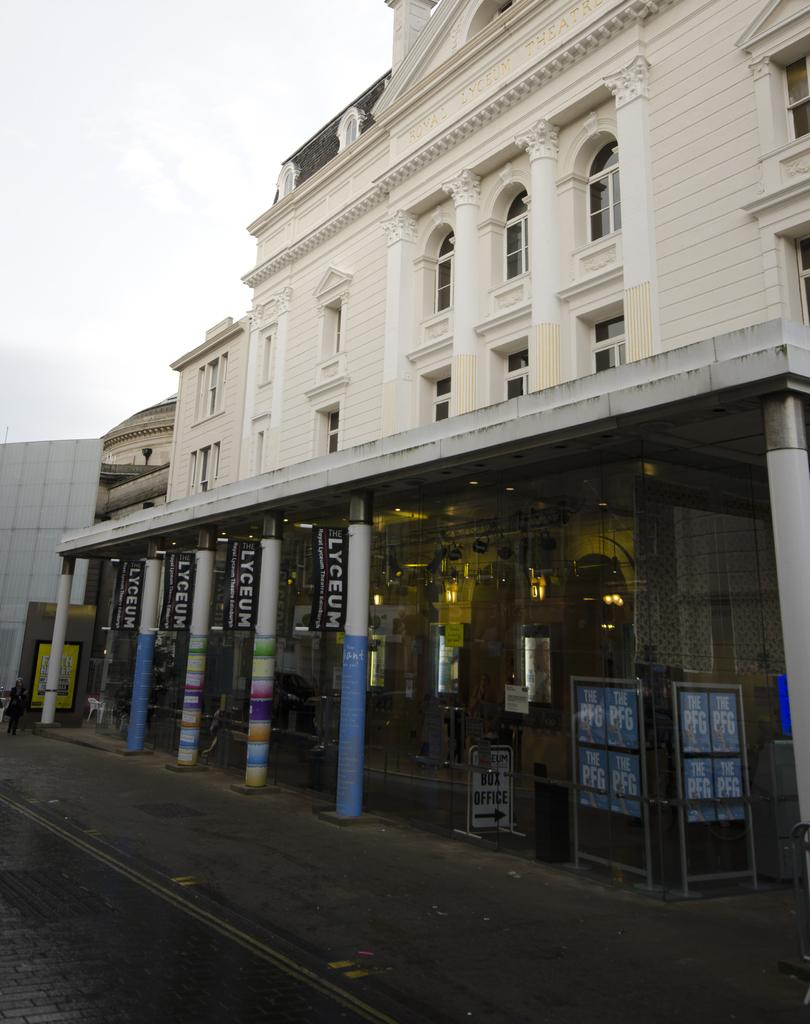What type of structures can be seen in the image? There are buildings in the image. What else is visible on the road in the image? There is a signboard visible on the road in the image. What type of competition is taking place in the image? There is no competition present in the image; it features buildings and a signboard on the road. Where is the jelly located in the image? There is no jelly present in the image. 